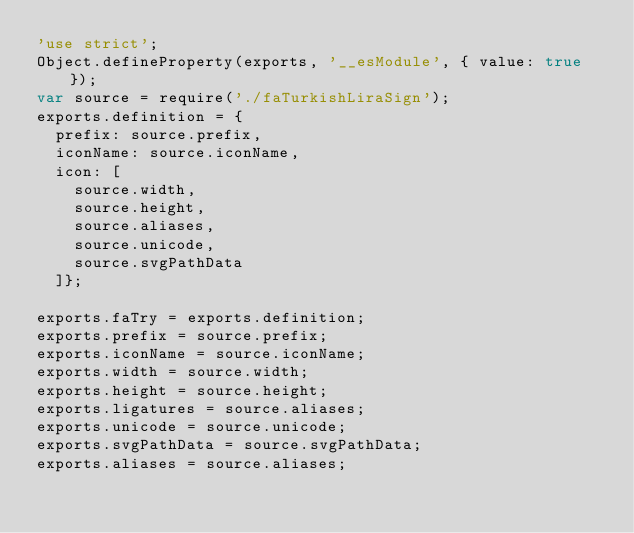<code> <loc_0><loc_0><loc_500><loc_500><_JavaScript_>'use strict';
Object.defineProperty(exports, '__esModule', { value: true });
var source = require('./faTurkishLiraSign');
exports.definition = {
  prefix: source.prefix,
  iconName: source.iconName,
  icon: [
    source.width,
    source.height,
    source.aliases,
    source.unicode,
    source.svgPathData
  ]};

exports.faTry = exports.definition;
exports.prefix = source.prefix;
exports.iconName = source.iconName;
exports.width = source.width;
exports.height = source.height;
exports.ligatures = source.aliases;
exports.unicode = source.unicode;
exports.svgPathData = source.svgPathData;
exports.aliases = source.aliases;</code> 